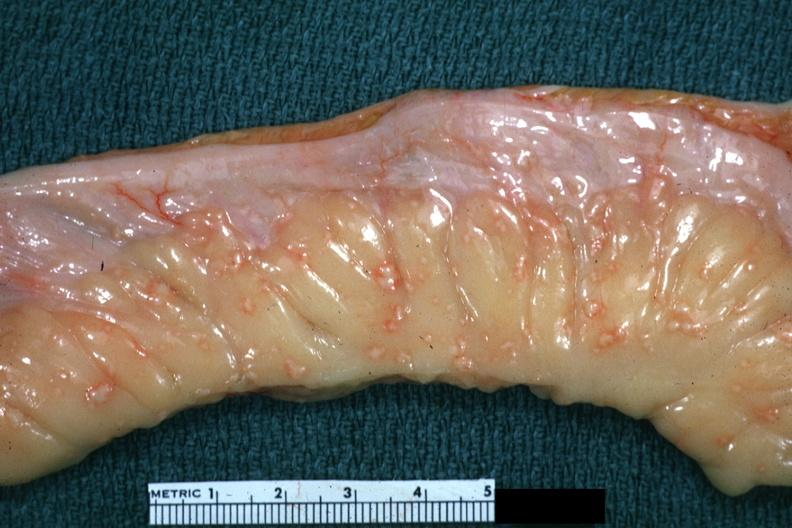does carcinomatosis show rather close-up excellent depiction of lesions of tuberculous peritonitis?
Answer the question using a single word or phrase. No 